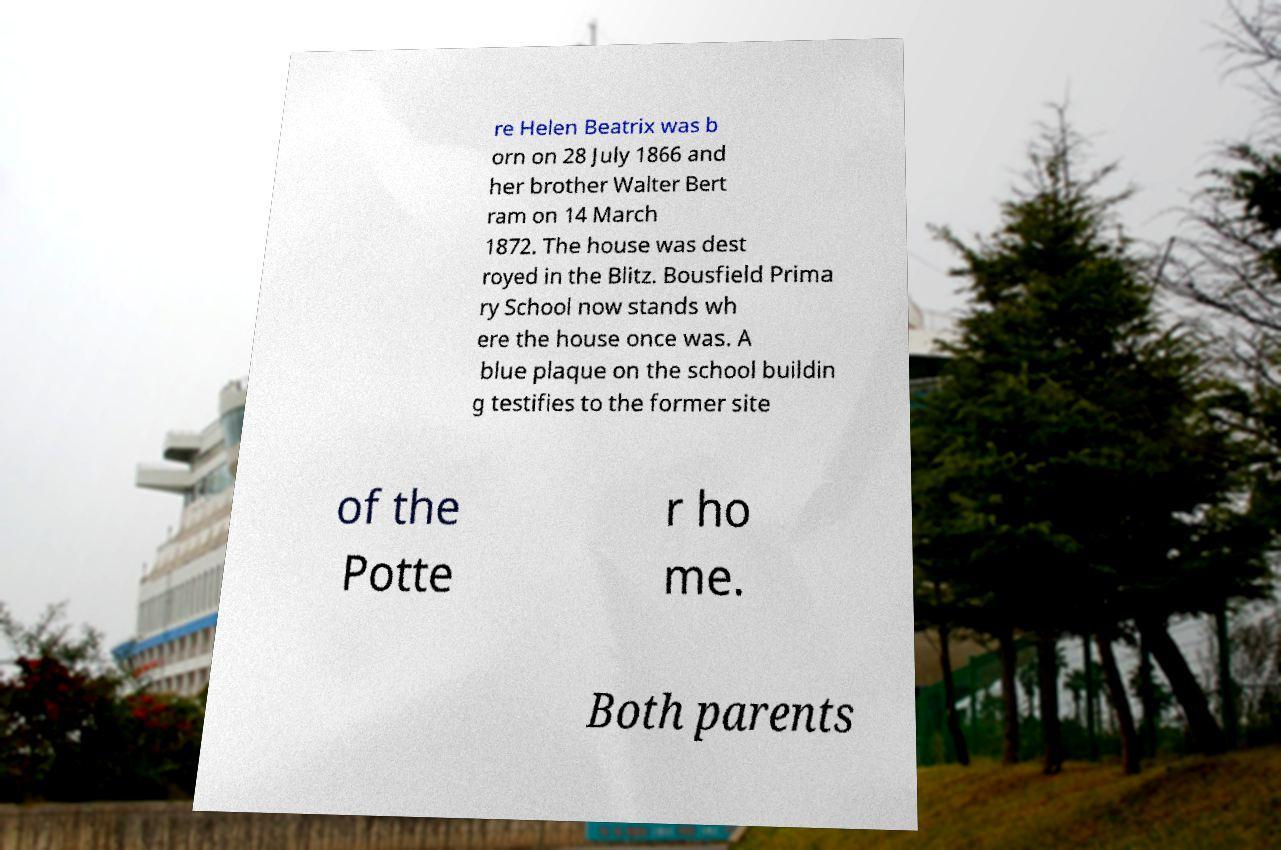Could you extract and type out the text from this image? re Helen Beatrix was b orn on 28 July 1866 and her brother Walter Bert ram on 14 March 1872. The house was dest royed in the Blitz. Bousfield Prima ry School now stands wh ere the house once was. A blue plaque on the school buildin g testifies to the former site of the Potte r ho me. Both parents 